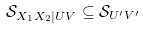<formula> <loc_0><loc_0><loc_500><loc_500>\mathcal { S } _ { X _ { 1 } X _ { 2 } | U V } \subseteq \mathcal { S } _ { U ^ { \prime } V ^ { \prime } }</formula> 